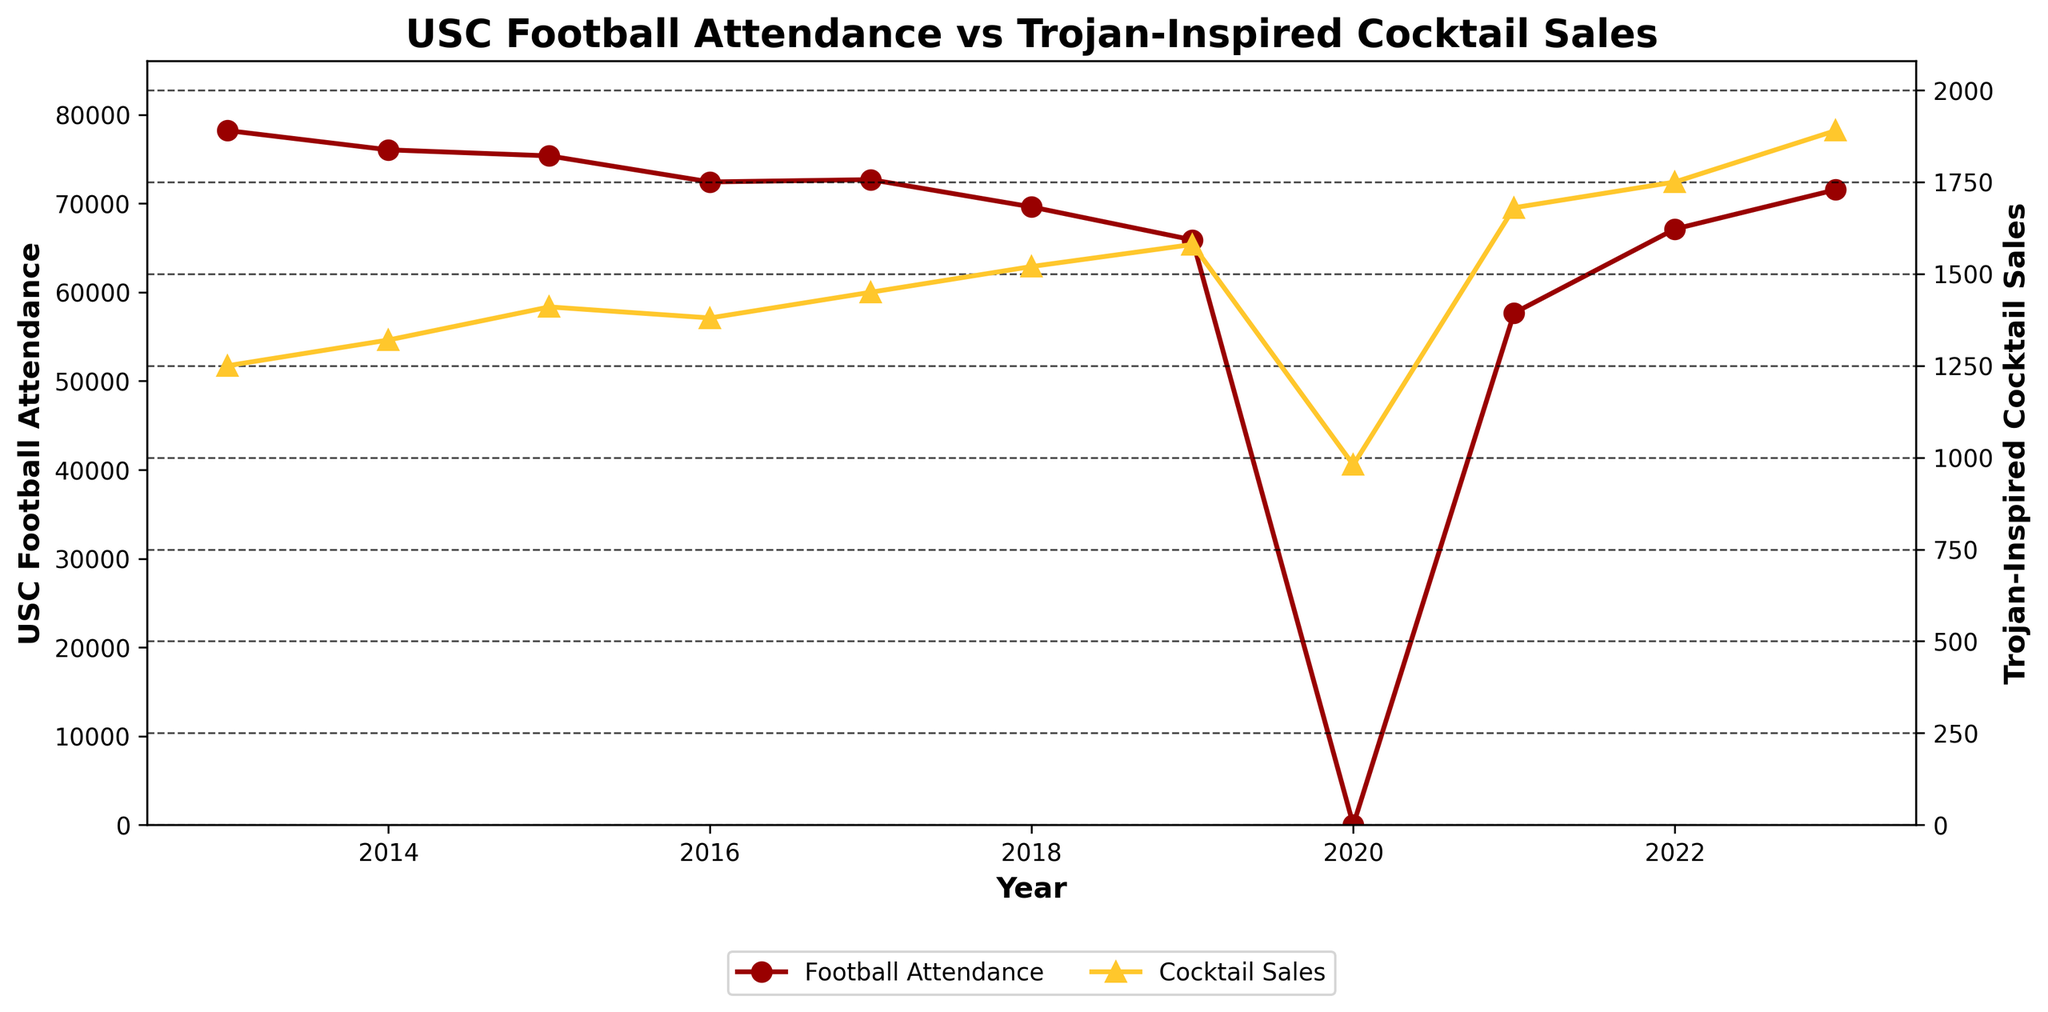What year had the highest Trojan-Inspired Cocktail Sales? Examine the plot for the year with the tallest yellow line (which represents the cocktail sales). The tallest line is in 2023.
Answer: 2023 How did USC Football Attendance change from 2013 to 2023? Track the trend of the red line (representing USC Football Attendance) from 2013 to 2023. There is an overall decrease with a slight increase towards 2023.
Answer: Decreased overall with slight increase at the end Which year saw the biggest drop in USC Football Attendance? Look for the steepest decline in the red line representing football attendance. The steepest drop is between 2019 and 2020.
Answer: 2020 What's the difference in Trojan-Inspired Cocktail Sales between 2013 and 2023? Check the corresponding values for cocktail sales in 2013 and 2023 and subtract the former from the latter. 2013 has 1250, and 2023 has 1890. The difference is 1890 - 1250 = 640.
Answer: 640 Compare USC Football Attendance and Trojan-Inspired Cocktail Sales in 2017. Which was higher and by how much? Look at the values for both series in 2017, which are 72683 (attendance) and 1450 (sales). Attendance is higher. Calculated difference is 72683 - 1450 = 71233.
Answer: Attendance was higher by 71233 Did Trojan-Inspired Cocktail Sales show any decline in any year? Observe the trend of the yellow line representing cocktail sales. The line consistently rises each year, except for a dip in 2020.
Answer: Yes, in 2020 In which year did USC Football Attendance start recovering after hitting its lowest point? Identify the lowest point on the red line (in 2020) and then look for the first upward movement (recovery) year, which is 2021.
Answer: 2021 What was the average Trojan-Inspired Cocktail Sales from 2018 to 2020? Add the sales figures for 2018 (1520), 2019 (1580), and 2020 (980), then divide by the number of years (3). (1520 + 1580 + 980) / 3 = 1406.67.
Answer: 1406.67 